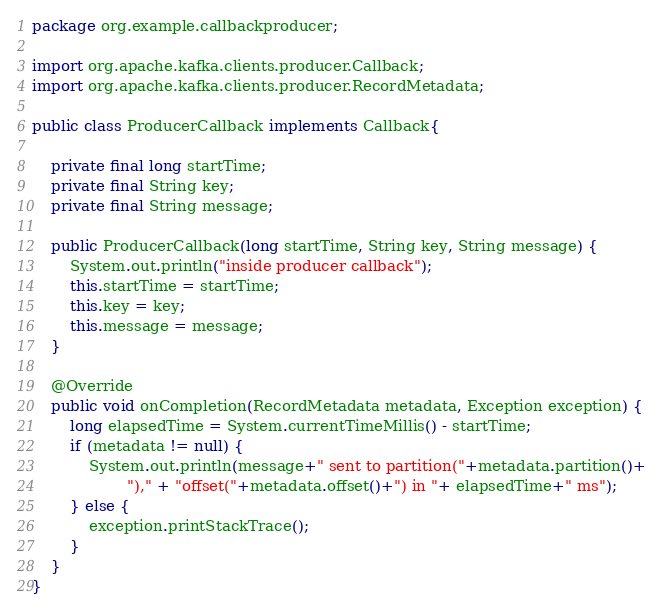Convert code to text. <code><loc_0><loc_0><loc_500><loc_500><_Java_>package org.example.callbackproducer;

import org.apache.kafka.clients.producer.Callback;
import org.apache.kafka.clients.producer.RecordMetadata;

public class ProducerCallback implements Callback{

	private final long startTime;
	private final String key;
	private final String message;

	public ProducerCallback(long startTime, String key, String message) {
		System.out.println("inside producer callback");
		this.startTime = startTime;
		this.key = key;
		this.message = message;
	}
	
	@Override
	public void onCompletion(RecordMetadata metadata, Exception exception) {
		long elapsedTime = System.currentTimeMillis() - startTime;
		if (metadata != null) {
			System.out.println(message+" sent to partition("+metadata.partition()+
					")," + "offset("+metadata.offset()+") in "+ elapsedTime+" ms");
		} else {
			exception.printStackTrace();
		}
	}
}</code> 